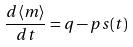Convert formula to latex. <formula><loc_0><loc_0><loc_500><loc_500>\frac { d \langle m \rangle } { d t } = q - p s ( t )</formula> 